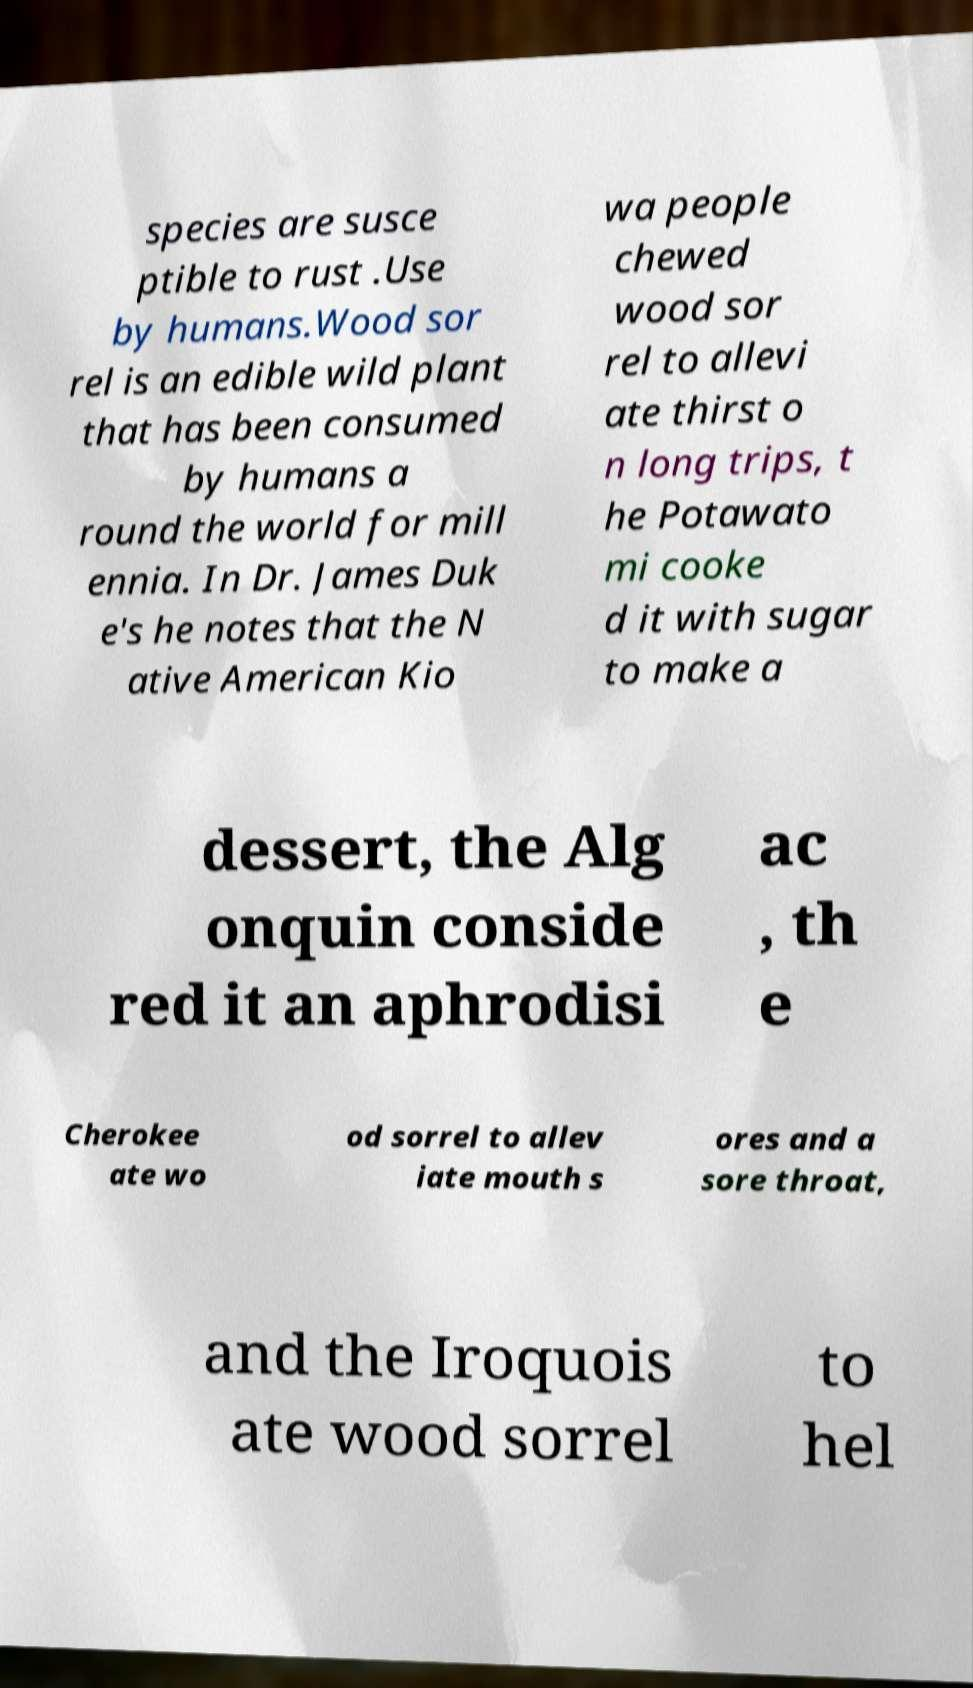Can you read and provide the text displayed in the image?This photo seems to have some interesting text. Can you extract and type it out for me? species are susce ptible to rust .Use by humans.Wood sor rel is an edible wild plant that has been consumed by humans a round the world for mill ennia. In Dr. James Duk e's he notes that the N ative American Kio wa people chewed wood sor rel to allevi ate thirst o n long trips, t he Potawato mi cooke d it with sugar to make a dessert, the Alg onquin conside red it an aphrodisi ac , th e Cherokee ate wo od sorrel to allev iate mouth s ores and a sore throat, and the Iroquois ate wood sorrel to hel 